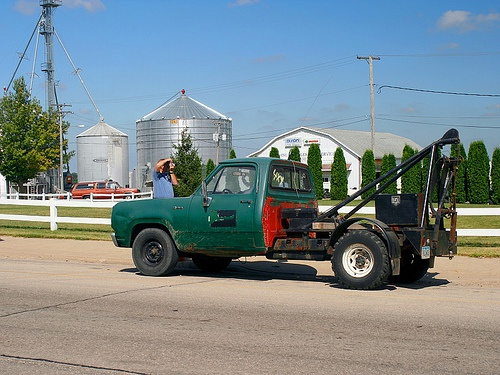Describe the objects in this image and their specific colors. I can see truck in lightblue, black, teal, gray, and darkgreen tones, car in lightblue, salmon, gray, and brown tones, and people in lightblue, gray, black, and darkgray tones in this image. 